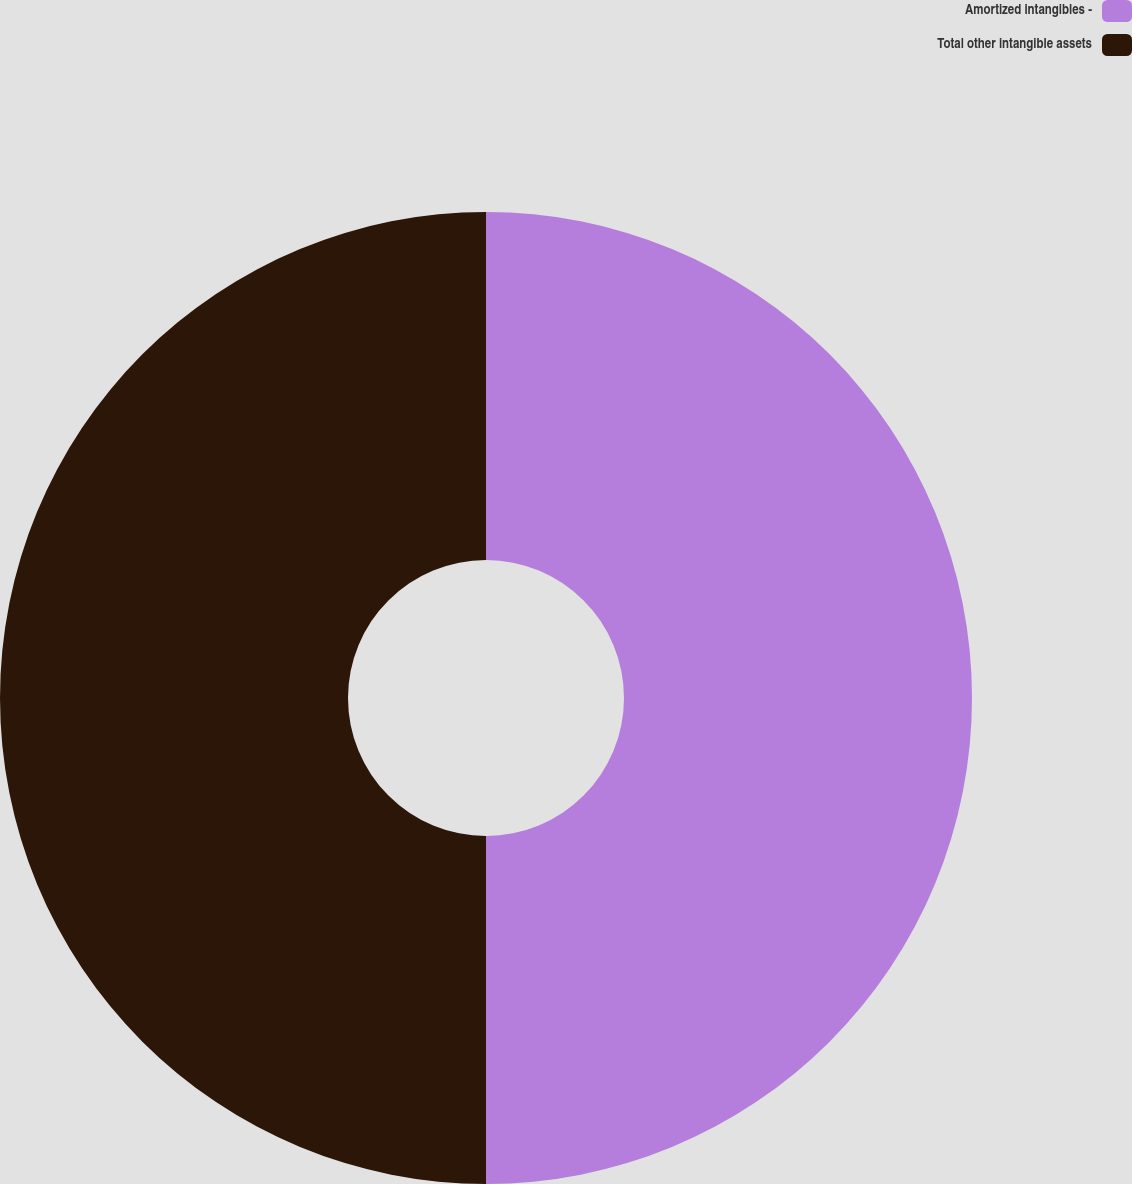<chart> <loc_0><loc_0><loc_500><loc_500><pie_chart><fcel>Amortized intangibles -<fcel>Total other intangible assets<nl><fcel>50.0%<fcel>50.0%<nl></chart> 